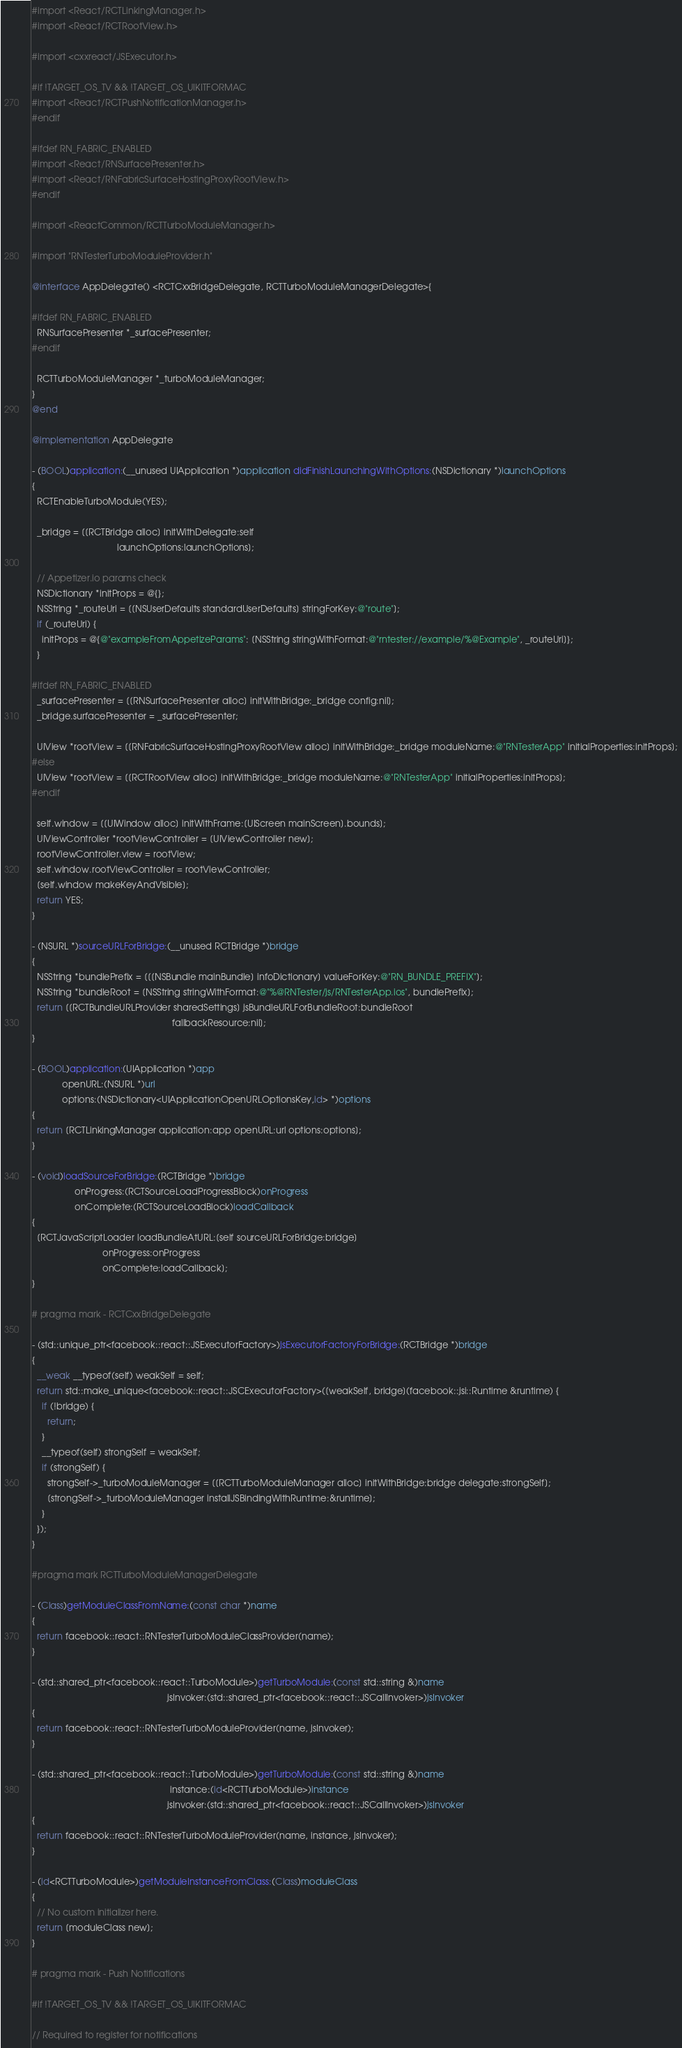<code> <loc_0><loc_0><loc_500><loc_500><_ObjectiveC_>#import <React/RCTLinkingManager.h>
#import <React/RCTRootView.h>

#import <cxxreact/JSExecutor.h>

#if !TARGET_OS_TV && !TARGET_OS_UIKITFORMAC
#import <React/RCTPushNotificationManager.h>
#endif

#ifdef RN_FABRIC_ENABLED
#import <React/RNSurfacePresenter.h>
#import <React/RNFabricSurfaceHostingProxyRootView.h>
#endif

#import <ReactCommon/RCTTurboModuleManager.h>

#import "RNTesterTurboModuleProvider.h"

@interface AppDelegate() <RCTCxxBridgeDelegate, RCTTurboModuleManagerDelegate>{

#ifdef RN_FABRIC_ENABLED
  RNSurfacePresenter *_surfacePresenter;
#endif

  RCTTurboModuleManager *_turboModuleManager;
}
@end

@implementation AppDelegate

- (BOOL)application:(__unused UIApplication *)application didFinishLaunchingWithOptions:(NSDictionary *)launchOptions
{
  RCTEnableTurboModule(YES);

  _bridge = [[RCTBridge alloc] initWithDelegate:self
                                  launchOptions:launchOptions];

  // Appetizer.io params check
  NSDictionary *initProps = @{};
  NSString *_routeUri = [[NSUserDefaults standardUserDefaults] stringForKey:@"route"];
  if (_routeUri) {
    initProps = @{@"exampleFromAppetizeParams": [NSString stringWithFormat:@"rntester://example/%@Example", _routeUri]};
  }

#ifdef RN_FABRIC_ENABLED
  _surfacePresenter = [[RNSurfacePresenter alloc] initWithBridge:_bridge config:nil];
  _bridge.surfacePresenter = _surfacePresenter;

  UIView *rootView = [[RNFabricSurfaceHostingProxyRootView alloc] initWithBridge:_bridge moduleName:@"RNTesterApp" initialProperties:initProps];
#else
  UIView *rootView = [[RCTRootView alloc] initWithBridge:_bridge moduleName:@"RNTesterApp" initialProperties:initProps];
#endif

  self.window = [[UIWindow alloc] initWithFrame:[UIScreen mainScreen].bounds];
  UIViewController *rootViewController = [UIViewController new];
  rootViewController.view = rootView;
  self.window.rootViewController = rootViewController;
  [self.window makeKeyAndVisible];
  return YES;
}

- (NSURL *)sourceURLForBridge:(__unused RCTBridge *)bridge
{
  NSString *bundlePrefix = [[[NSBundle mainBundle] infoDictionary] valueForKey:@"RN_BUNDLE_PREFIX"];
  NSString *bundleRoot = [NSString stringWithFormat:@"%@RNTester/js/RNTesterApp.ios", bundlePrefix];
  return [[RCTBundleURLProvider sharedSettings] jsBundleURLForBundleRoot:bundleRoot
                                                        fallbackResource:nil];
}

- (BOOL)application:(UIApplication *)app
            openURL:(NSURL *)url
            options:(NSDictionary<UIApplicationOpenURLOptionsKey,id> *)options
{
  return [RCTLinkingManager application:app openURL:url options:options];
}

- (void)loadSourceForBridge:(RCTBridge *)bridge
                 onProgress:(RCTSourceLoadProgressBlock)onProgress
                 onComplete:(RCTSourceLoadBlock)loadCallback
{
  [RCTJavaScriptLoader loadBundleAtURL:[self sourceURLForBridge:bridge]
                            onProgress:onProgress
                            onComplete:loadCallback];
}

# pragma mark - RCTCxxBridgeDelegate

- (std::unique_ptr<facebook::react::JSExecutorFactory>)jsExecutorFactoryForBridge:(RCTBridge *)bridge
{
  __weak __typeof(self) weakSelf = self;
  return std::make_unique<facebook::react::JSCExecutorFactory>([weakSelf, bridge](facebook::jsi::Runtime &runtime) {
    if (!bridge) {
      return;
    }
    __typeof(self) strongSelf = weakSelf;
    if (strongSelf) {
      strongSelf->_turboModuleManager = [[RCTTurboModuleManager alloc] initWithBridge:bridge delegate:strongSelf];
      [strongSelf->_turboModuleManager installJSBindingWithRuntime:&runtime];
    }
  });
}

#pragma mark RCTTurboModuleManagerDelegate

- (Class)getModuleClassFromName:(const char *)name
{
  return facebook::react::RNTesterTurboModuleClassProvider(name);
}

- (std::shared_ptr<facebook::react::TurboModule>)getTurboModule:(const std::string &)name
                                                      jsInvoker:(std::shared_ptr<facebook::react::JSCallInvoker>)jsInvoker
{
  return facebook::react::RNTesterTurboModuleProvider(name, jsInvoker);
}

- (std::shared_ptr<facebook::react::TurboModule>)getTurboModule:(const std::string &)name
                                                       instance:(id<RCTTurboModule>)instance
                                                      jsInvoker:(std::shared_ptr<facebook::react::JSCallInvoker>)jsInvoker
{
  return facebook::react::RNTesterTurboModuleProvider(name, instance, jsInvoker);
}

- (id<RCTTurboModule>)getModuleInstanceFromClass:(Class)moduleClass
{
  // No custom initializer here.
  return [moduleClass new];
}

# pragma mark - Push Notifications

#if !TARGET_OS_TV && !TARGET_OS_UIKITFORMAC

// Required to register for notifications</code> 